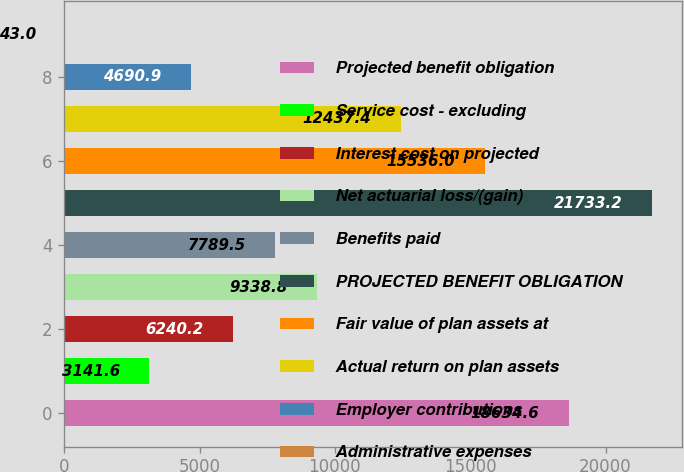Convert chart. <chart><loc_0><loc_0><loc_500><loc_500><bar_chart><fcel>Projected benefit obligation<fcel>Service cost - excluding<fcel>Interest cost on projected<fcel>Net actuarial loss/(gain)<fcel>Benefits paid<fcel>PROJECTED BENEFIT OBLIGATION<fcel>Fair value of plan assets at<fcel>Actual return on plan assets<fcel>Employer contributions<fcel>Administrative expenses<nl><fcel>18634.6<fcel>3141.6<fcel>6240.2<fcel>9338.8<fcel>7789.5<fcel>21733.2<fcel>15536<fcel>12437.4<fcel>4690.9<fcel>43<nl></chart> 